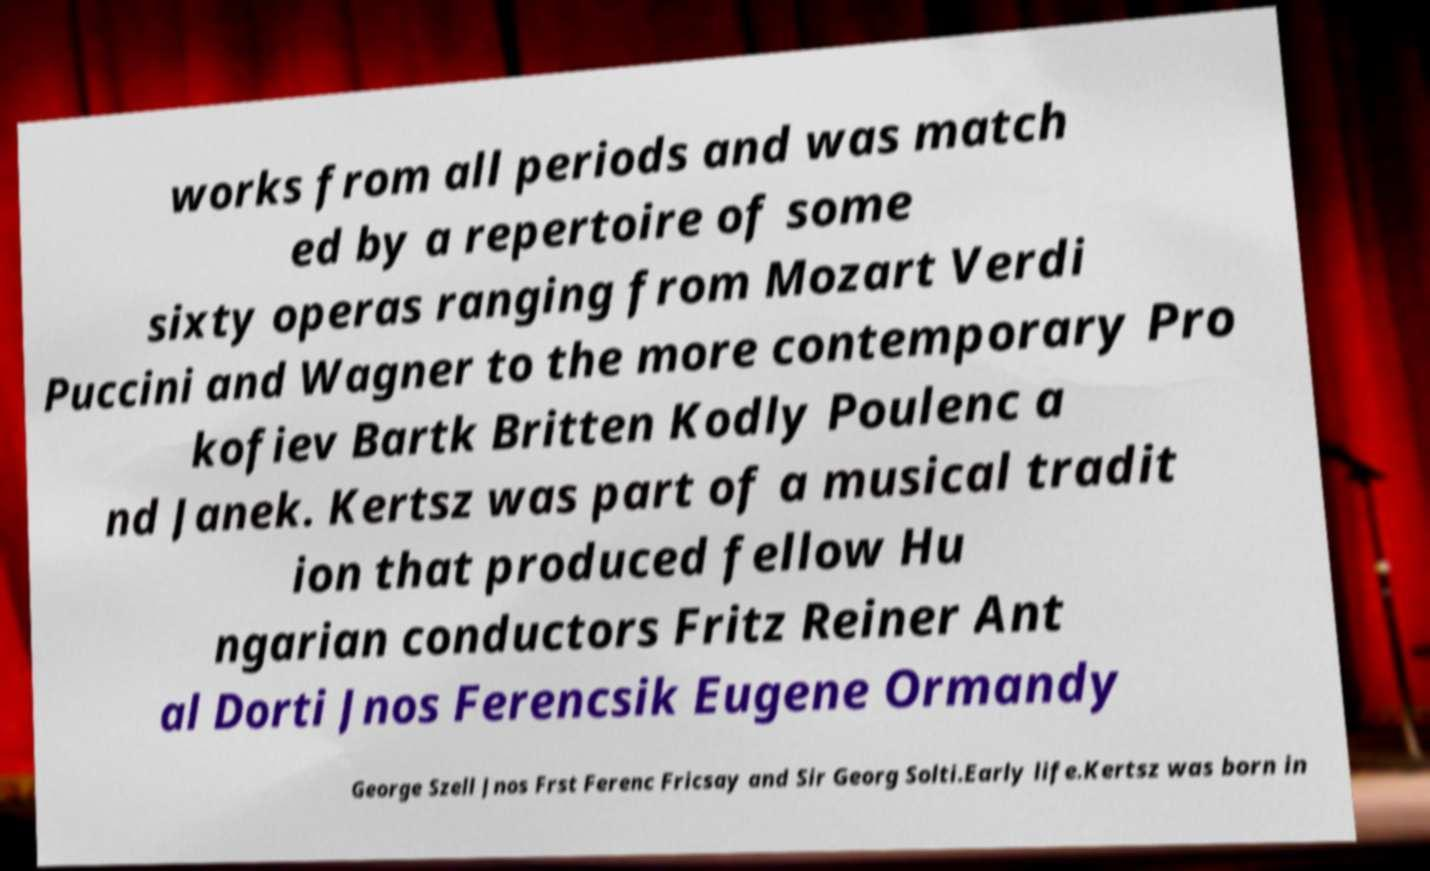Can you read and provide the text displayed in the image?This photo seems to have some interesting text. Can you extract and type it out for me? works from all periods and was match ed by a repertoire of some sixty operas ranging from Mozart Verdi Puccini and Wagner to the more contemporary Pro kofiev Bartk Britten Kodly Poulenc a nd Janek. Kertsz was part of a musical tradit ion that produced fellow Hu ngarian conductors Fritz Reiner Ant al Dorti Jnos Ferencsik Eugene Ormandy George Szell Jnos Frst Ferenc Fricsay and Sir Georg Solti.Early life.Kertsz was born in 